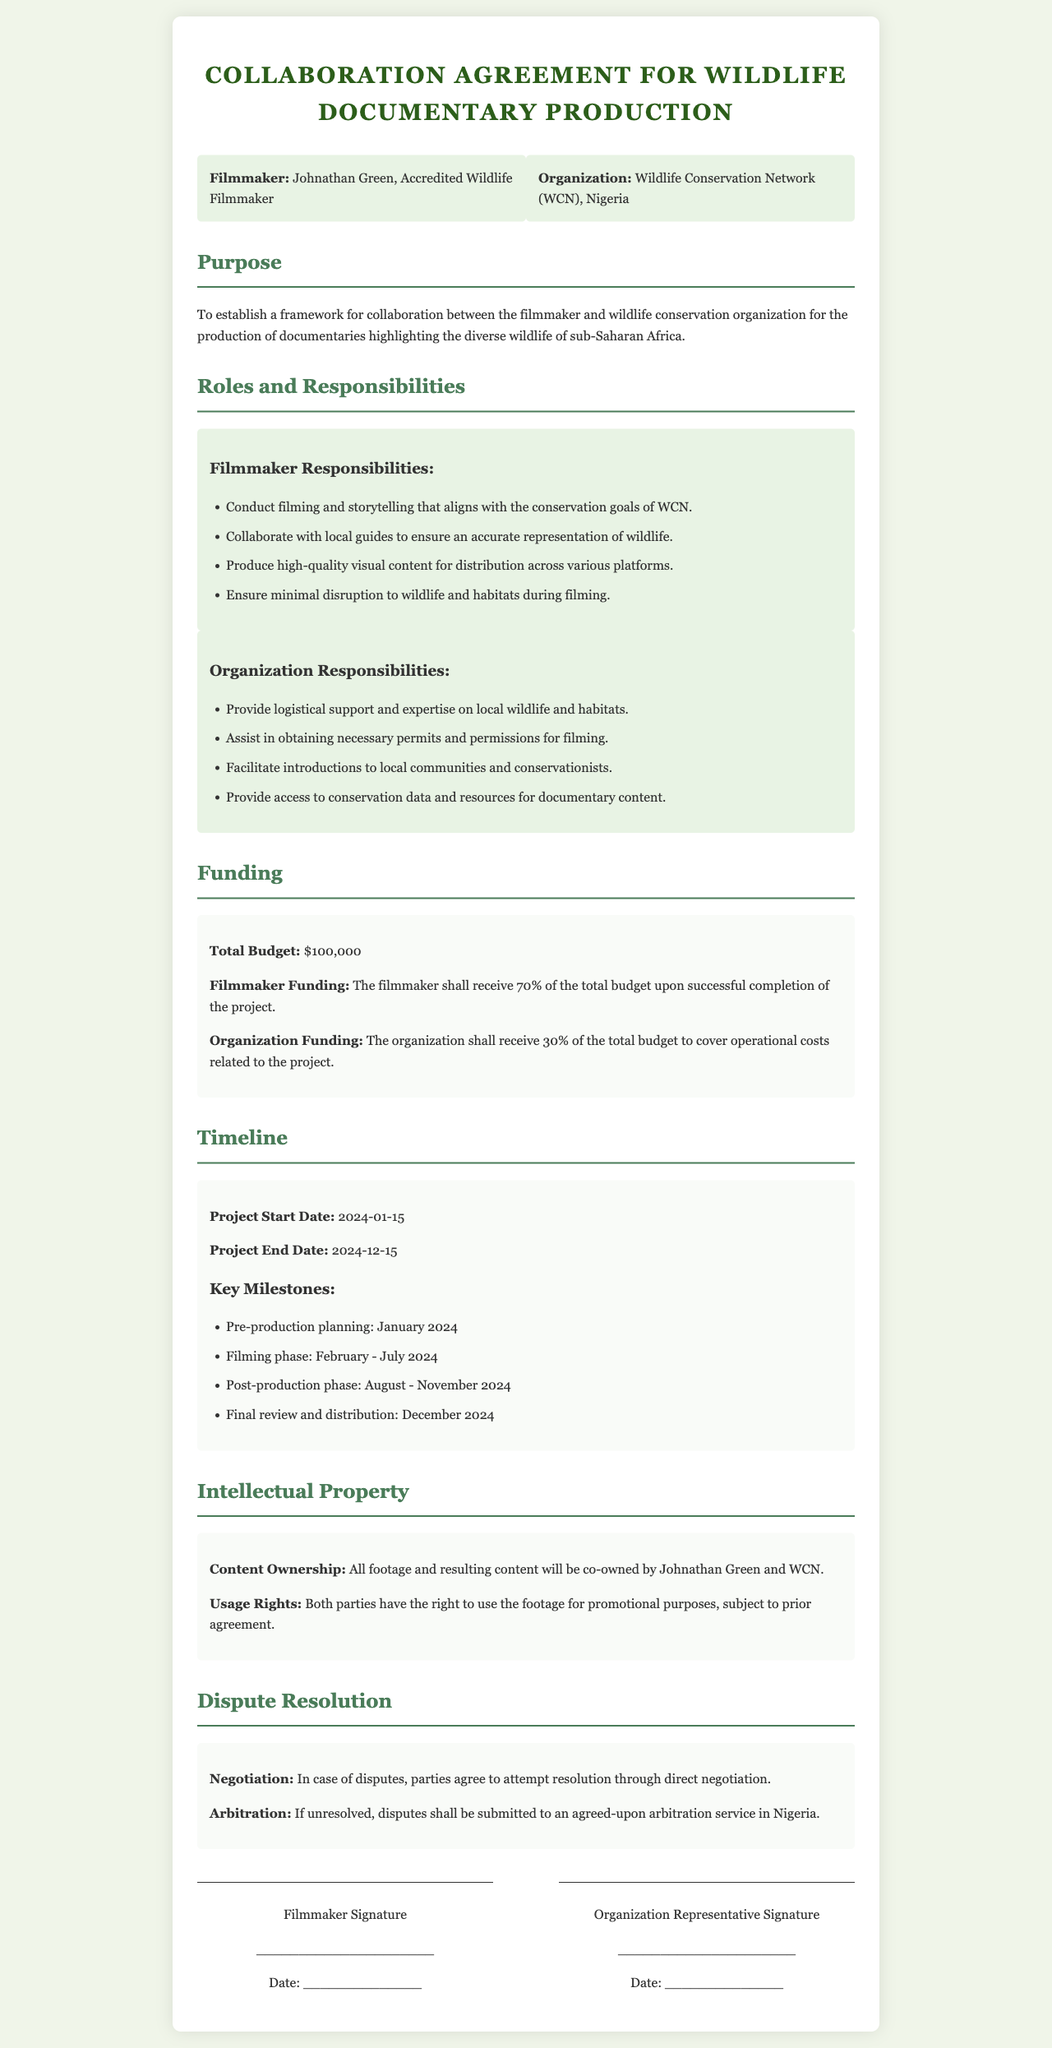What is the title of the agreement? The title is prominently displayed at the top of the document and indicates its purpose as a collaboration framework.
Answer: Collaboration Agreement for Wildlife Documentary Production Who is the filmmaker mentioned in the document? The name of the filmmaker is listed in the parties section, clarifying his role in the agreement.
Answer: Johnathan Green What percentage of the total budget is allocated to the organization? The funding section specifies the division of the total budget between the filmmaker and the organization.
Answer: 30% What are the key milestones for the filming phase? The timeline section outlines the various stages of the project, including when filming occurs.
Answer: February - July 2024 What is the start date of the project? The timeline clearly indicates the official commencement of the project by stating the date.
Answer: 2024-01-15 What is the dispute resolution method agreed upon? The document provides a clear process for resolving any disagreements that may arise during the collaboration.
Answer: Negotiation How will the footage ownership be shared? The intellectual property section specifies how the ownership of content produced during the project will be managed.
Answer: Co-owned by Johnathan Green and WCN What is the total budget for the project? The funding section explicitly states the total financial allocation for the documentary project.
Answer: $100,000 